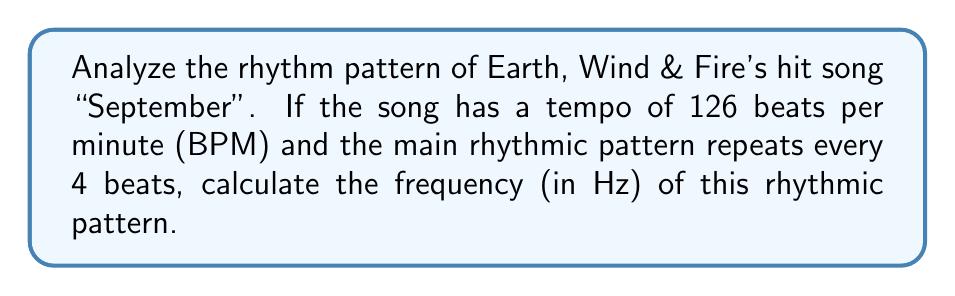Provide a solution to this math problem. To solve this problem, we'll follow these steps:

1. Convert the tempo from beats per minute (BPM) to beats per second:
   $$\text{Beats per second} = \frac{126 \text{ BPM}}{60 \text{ seconds}} = 2.1 \text{ beats/second}$$

2. Determine the duration of one complete rhythmic pattern:
   The pattern repeats every 4 beats, so:
   $$\text{Pattern duration} = \frac{4 \text{ beats}}{2.1 \text{ beats/second}} = 1.905 \text{ seconds}$$

3. Calculate the frequency of the rhythmic pattern:
   Frequency is the inverse of the period (duration), so:
   $$\text{Frequency} = \frac{1}{\text{Pattern duration}} = \frac{1}{1.905 \text{ seconds}} = 0.525 \text{ Hz}$$

Therefore, the frequency of the main rhythmic pattern in "September" is approximately 0.525 Hz.
Answer: 0.525 Hz 